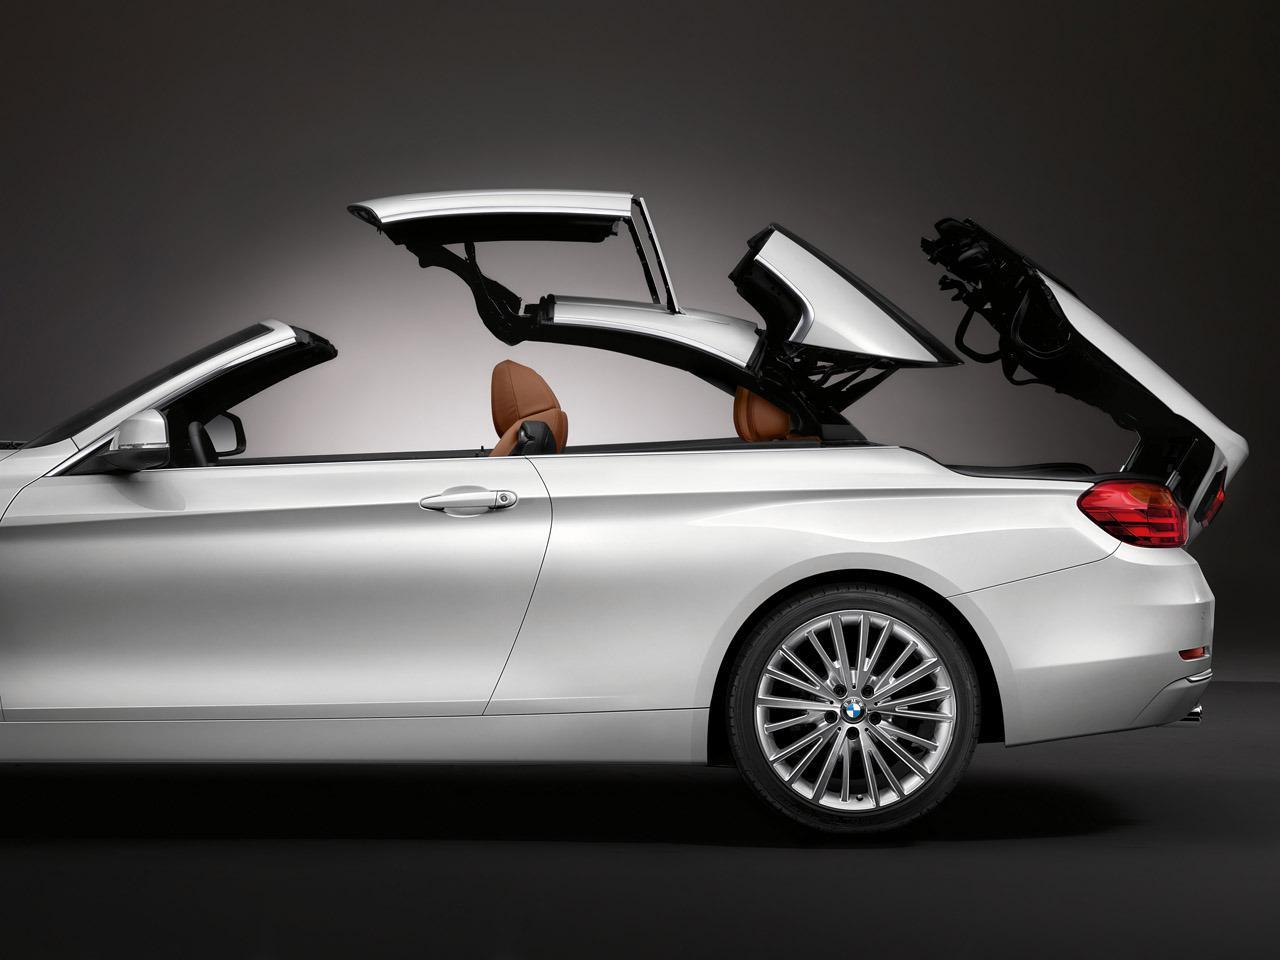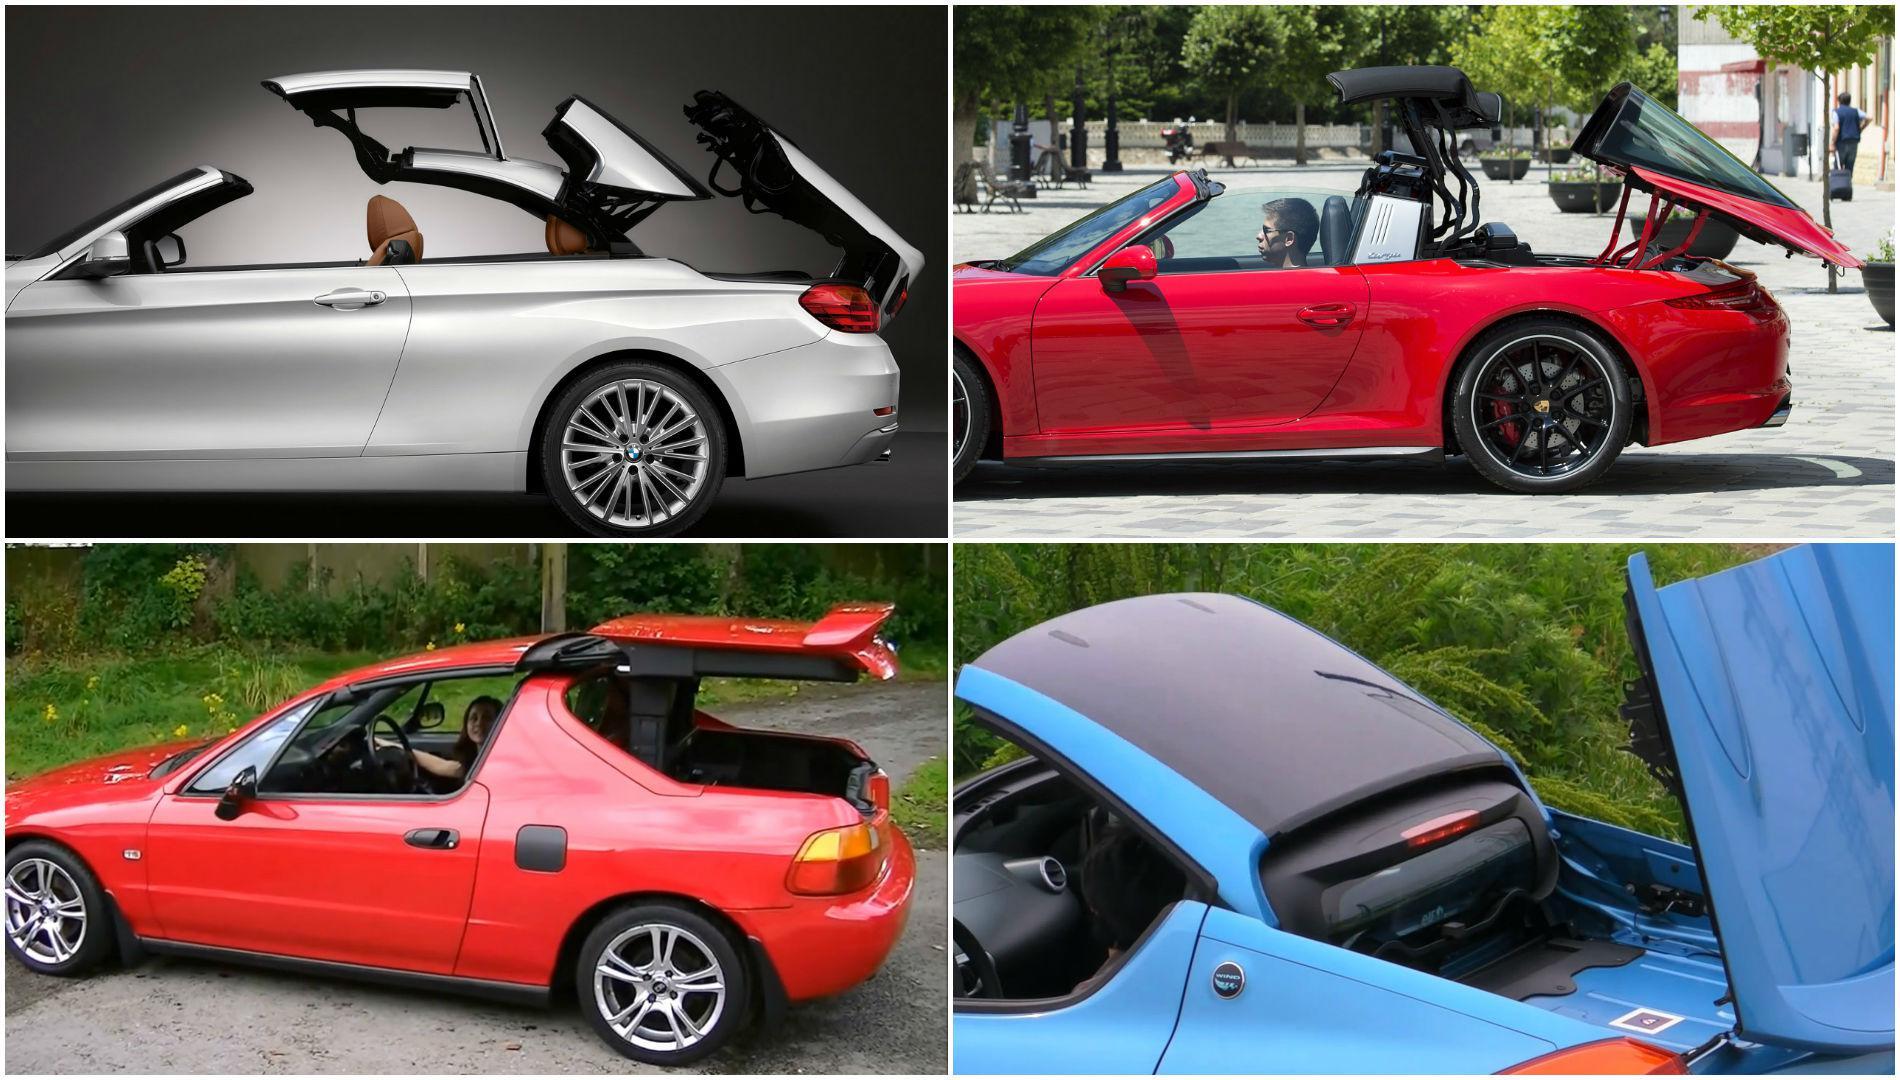The first image is the image on the left, the second image is the image on the right. For the images shown, is this caption "The right image contains at least one red sports car." true? Answer yes or no. Yes. The first image is the image on the left, the second image is the image on the right. For the images displayed, is the sentence "Right and left images each contain a convertible in side view with its top partly raised." factually correct? Answer yes or no. Yes. 